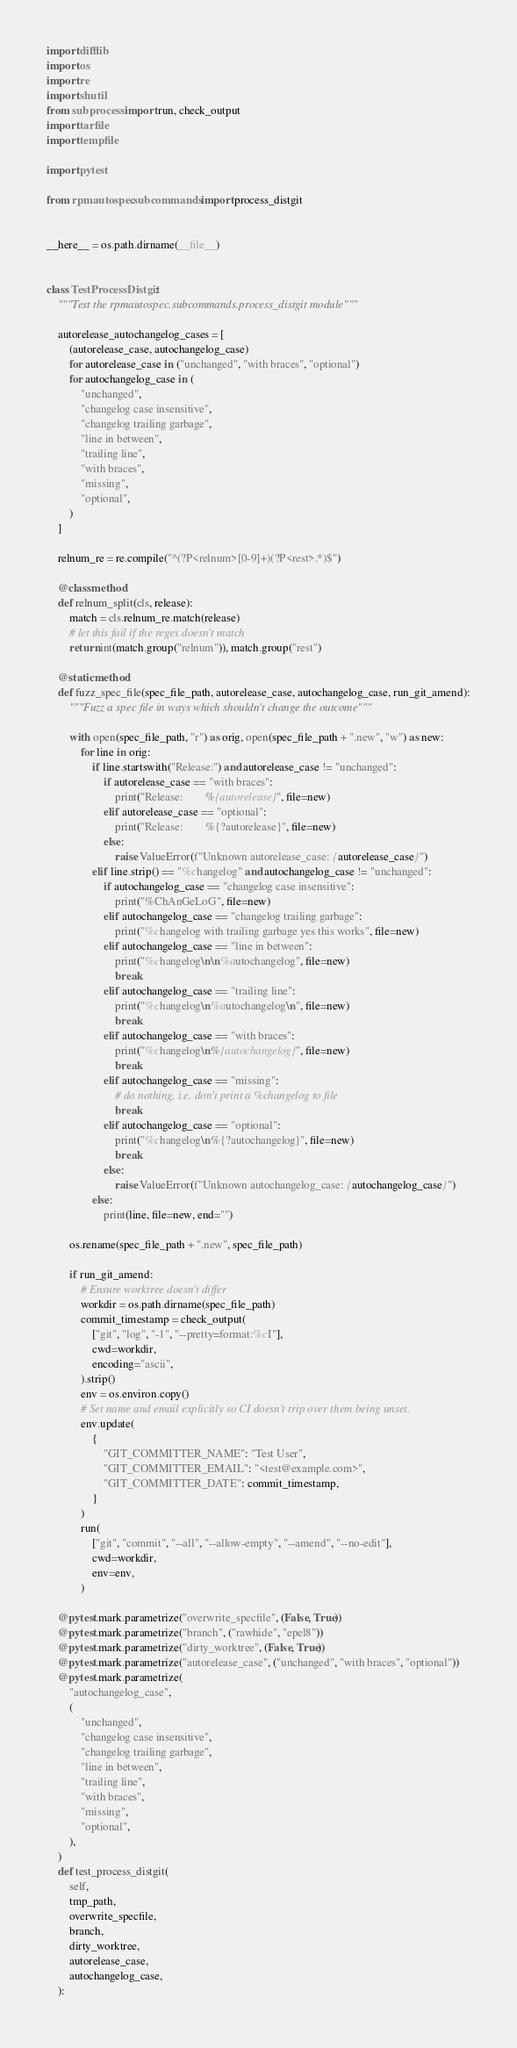Convert code to text. <code><loc_0><loc_0><loc_500><loc_500><_Python_>import difflib
import os
import re
import shutil
from subprocess import run, check_output
import tarfile
import tempfile

import pytest

from rpmautospec.subcommands import process_distgit


__here__ = os.path.dirname(__file__)


class TestProcessDistgit:
    """Test the rpmautospec.subcommands.process_distgit module"""

    autorelease_autochangelog_cases = [
        (autorelease_case, autochangelog_case)
        for autorelease_case in ("unchanged", "with braces", "optional")
        for autochangelog_case in (
            "unchanged",
            "changelog case insensitive",
            "changelog trailing garbage",
            "line in between",
            "trailing line",
            "with braces",
            "missing",
            "optional",
        )
    ]

    relnum_re = re.compile("^(?P<relnum>[0-9]+)(?P<rest>.*)$")

    @classmethod
    def relnum_split(cls, release):
        match = cls.relnum_re.match(release)
        # let this fail if the regex doesn't match
        return int(match.group("relnum")), match.group("rest")

    @staticmethod
    def fuzz_spec_file(spec_file_path, autorelease_case, autochangelog_case, run_git_amend):
        """Fuzz a spec file in ways which shouldn't change the outcome"""

        with open(spec_file_path, "r") as orig, open(spec_file_path + ".new", "w") as new:
            for line in orig:
                if line.startswith("Release:") and autorelease_case != "unchanged":
                    if autorelease_case == "with braces":
                        print("Release:        %{autorelease}", file=new)
                    elif autorelease_case == "optional":
                        print("Release:        %{?autorelease}", file=new)
                    else:
                        raise ValueError(f"Unknown autorelease_case: {autorelease_case}")
                elif line.strip() == "%changelog" and autochangelog_case != "unchanged":
                    if autochangelog_case == "changelog case insensitive":
                        print("%ChAnGeLoG", file=new)
                    elif autochangelog_case == "changelog trailing garbage":
                        print("%changelog with trailing garbage yes this works", file=new)
                    elif autochangelog_case == "line in between":
                        print("%changelog\n\n%autochangelog", file=new)
                        break
                    elif autochangelog_case == "trailing line":
                        print("%changelog\n%autochangelog\n", file=new)
                        break
                    elif autochangelog_case == "with braces":
                        print("%changelog\n%{autochangelog}", file=new)
                        break
                    elif autochangelog_case == "missing":
                        # do nothing, i.e. don't print a %changelog to file
                        break
                    elif autochangelog_case == "optional":
                        print("%changelog\n%{?autochangelog}", file=new)
                        break
                    else:
                        raise ValueError(f"Unknown autochangelog_case: {autochangelog_case}")
                else:
                    print(line, file=new, end="")

        os.rename(spec_file_path + ".new", spec_file_path)

        if run_git_amend:
            # Ensure worktree doesn't differ
            workdir = os.path.dirname(spec_file_path)
            commit_timestamp = check_output(
                ["git", "log", "-1", "--pretty=format:%cI"],
                cwd=workdir,
                encoding="ascii",
            ).strip()
            env = os.environ.copy()
            # Set name and email explicitly so CI doesn't trip over them being unset.
            env.update(
                {
                    "GIT_COMMITTER_NAME": "Test User",
                    "GIT_COMMITTER_EMAIL": "<test@example.com>",
                    "GIT_COMMITTER_DATE": commit_timestamp,
                }
            )
            run(
                ["git", "commit", "--all", "--allow-empty", "--amend", "--no-edit"],
                cwd=workdir,
                env=env,
            )

    @pytest.mark.parametrize("overwrite_specfile", (False, True))
    @pytest.mark.parametrize("branch", ("rawhide", "epel8"))
    @pytest.mark.parametrize("dirty_worktree", (False, True))
    @pytest.mark.parametrize("autorelease_case", ("unchanged", "with braces", "optional"))
    @pytest.mark.parametrize(
        "autochangelog_case",
        (
            "unchanged",
            "changelog case insensitive",
            "changelog trailing garbage",
            "line in between",
            "trailing line",
            "with braces",
            "missing",
            "optional",
        ),
    )
    def test_process_distgit(
        self,
        tmp_path,
        overwrite_specfile,
        branch,
        dirty_worktree,
        autorelease_case,
        autochangelog_case,
    ):</code> 